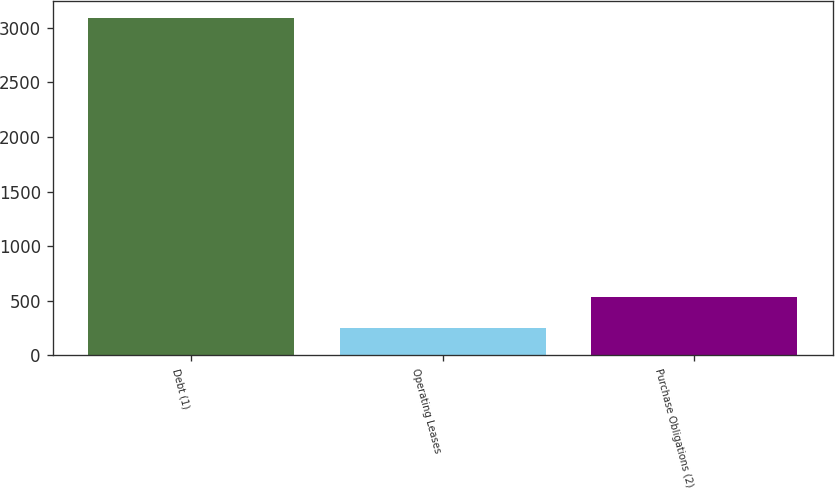Convert chart to OTSL. <chart><loc_0><loc_0><loc_500><loc_500><bar_chart><fcel>Debt (1)<fcel>Operating Leases<fcel>Purchase Obligations (2)<nl><fcel>3089<fcel>255<fcel>538.4<nl></chart> 